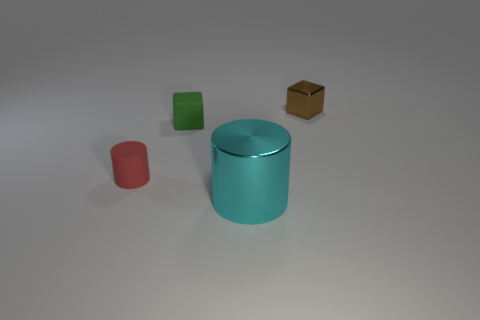There is a tiny thing that is on the right side of the small green rubber thing that is in front of the small brown metal block; what color is it? The tiny thing to the right of the small green object, which is in front of a small brown block, appears to be a white-gray color, due to its small size and the lighting it's a bit difficult to determine the exact color. 